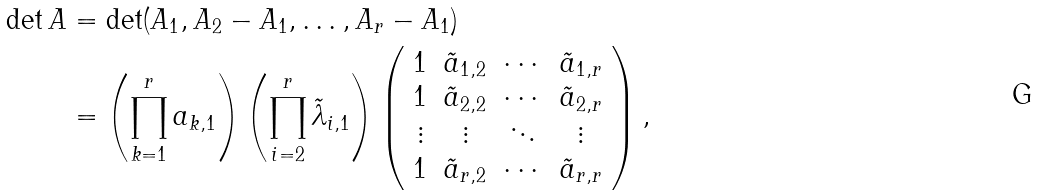Convert formula to latex. <formula><loc_0><loc_0><loc_500><loc_500>\det A & = \det ( A _ { 1 } , A _ { 2 } - A _ { 1 } , \dots , A _ { r } - A _ { 1 } ) \\ & = \left ( \prod _ { k = 1 } ^ { r } a _ { k , 1 } \right ) \left ( \prod _ { i = 2 } ^ { r } \tilde { \lambda } _ { i , 1 } \right ) \left ( \begin{array} { c c c c } 1 & \tilde { a } _ { 1 , 2 } & \cdots & \tilde { a } _ { 1 , r } \\ 1 & \tilde { a } _ { 2 , 2 } & \cdots & \tilde { a } _ { 2 , r } \\ \vdots & \vdots & \ddots & \vdots \\ 1 & \tilde { a } _ { r , 2 } & \cdots & \tilde { a } _ { r , r } \end{array} \right ) ,</formula> 